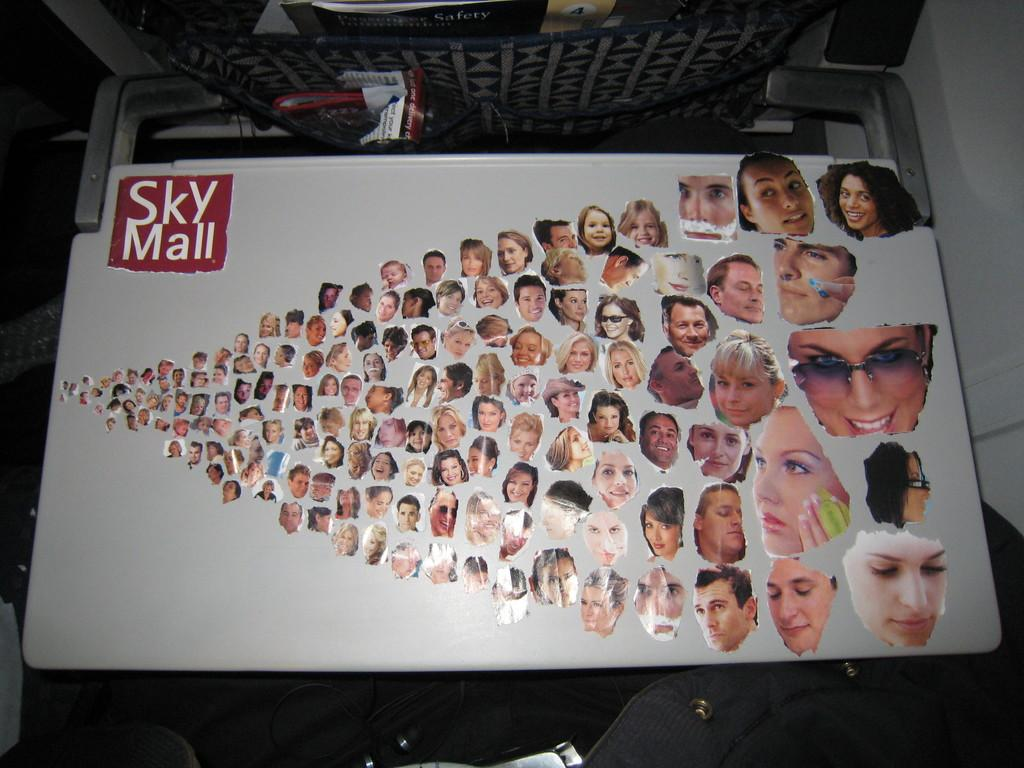What is the main object in the image? There is a whiteboard in the image. What is attached to the whiteboard? Photographs of different women are stuck on the whiteboard. Can you hear the goat making noise in the image? There is no goat present in the image, so it cannot be heard making any noise. 